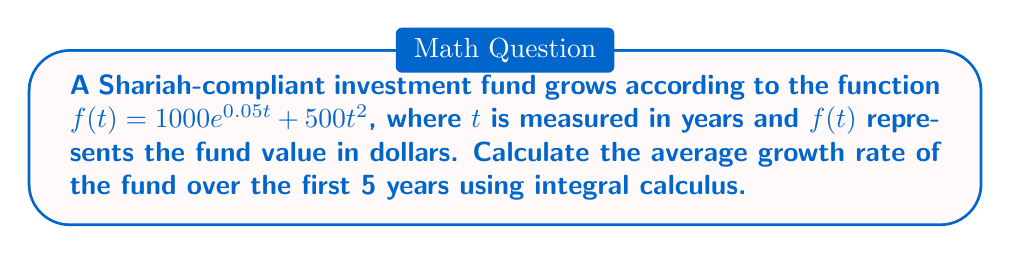Can you answer this question? To find the average growth rate, we need to follow these steps:

1. Calculate the total growth over the 5-year period:
   We need to find $f(5) - f(0)$.

   $f(0) = 1000e^{0.05 \cdot 0} + 500 \cdot 0^2 = 1000$
   $f(5) = 1000e^{0.05 \cdot 5} + 500 \cdot 5^2 = 1000e^{0.25} + 12500$

2. Calculate the average rate of change:
   The average rate of change is given by:
   $$\frac{f(5) - f(0)}{5 - 0} = \frac{1000e^{0.25} + 12500 - 1000}{5}$$

3. Use integral calculus to find the average growth rate:
   The average value of a function $f(t)$ over an interval $[a,b]$ is given by:
   $$\frac{1}{b-a} \int_{a}^{b} f'(t) dt$$

   First, we need to find $f'(t)$:
   $$f'(t) = 1000 \cdot 0.05e^{0.05t} + 1000t$$

   Now, we can calculate the average growth rate:
   $$\frac{1}{5-0} \int_{0}^{5} (1000 \cdot 0.05e^{0.05t} + 1000t) dt$$

4. Solve the integral:
   $$\frac{1}{5} [1000e^{0.05t} + 500t^2]_{0}^{5}$$
   $$= \frac{1}{5} [(1000e^{0.25} + 12500) - (1000 + 0)]$$
   $$= \frac{1000e^{0.25} + 11500}{5}$$

This result is identical to the average rate of change we calculated in step 2, confirming our calculation.
Answer: $\frac{1000e^{0.25} + 11500}{5}$ dollars per year 